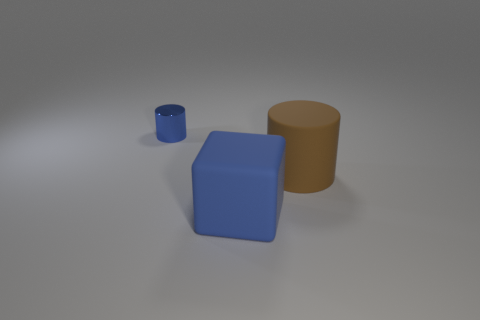Add 1 big objects. How many big objects exist? 3 Add 2 tiny things. How many objects exist? 5 Subtract all brown cylinders. How many cylinders are left? 1 Subtract 0 blue spheres. How many objects are left? 3 Subtract all cylinders. How many objects are left? 1 Subtract all brown cylinders. Subtract all brown cubes. How many cylinders are left? 1 Subtract all purple spheres. How many blue cylinders are left? 1 Subtract all red shiny balls. Subtract all tiny blue metallic things. How many objects are left? 2 Add 2 large rubber things. How many large rubber things are left? 4 